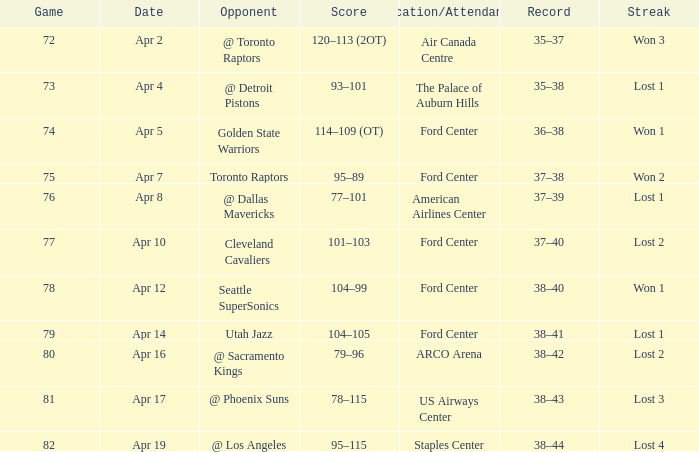Who was the opponent for game 75? Toronto Raptors. 